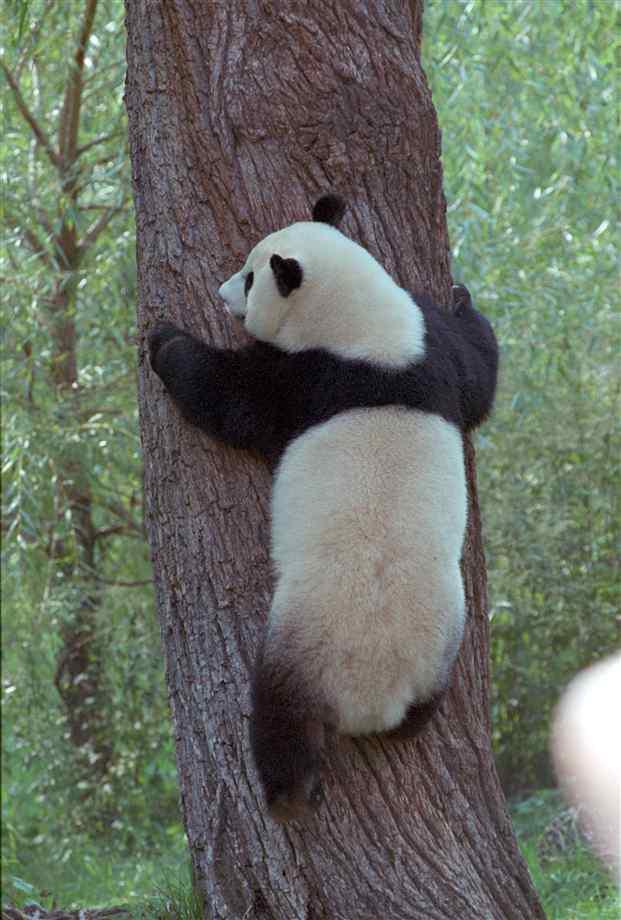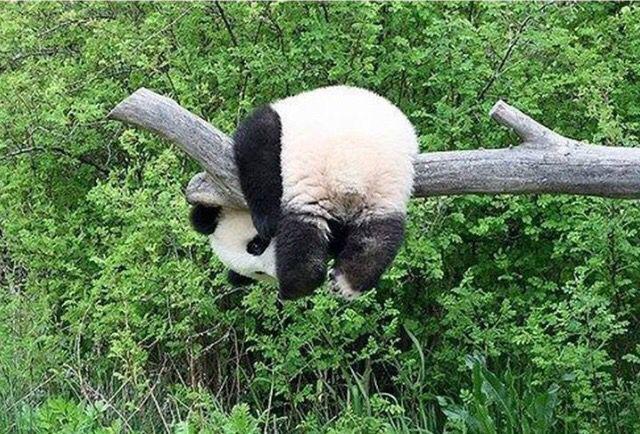The first image is the image on the left, the second image is the image on the right. Given the left and right images, does the statement "The panda in the image on the left is hanging against the side of a tree trunk." hold true? Answer yes or no. Yes. The first image is the image on the left, the second image is the image on the right. Examine the images to the left and right. Is the description "The right image shows one panda draped over part of a tree, with its hind legs hanging down." accurate? Answer yes or no. Yes. 